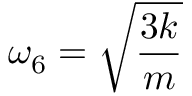Convert formula to latex. <formula><loc_0><loc_0><loc_500><loc_500>\omega _ { 6 } = \sqrt { \frac { 3 k } { m } }</formula> 